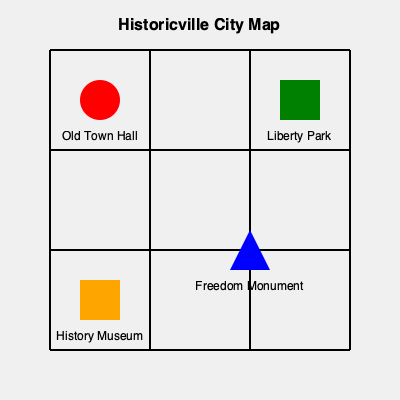Which landmark in Historicville is located at the intersection of the city's main north-south and east-west streets, and what historical event is it most closely associated with? To answer this question, we need to analyze the city map of Historicville and consider the historical significance of its landmarks. Let's break it down step-by-step:

1. Identify the main streets:
   - The map shows a grid of streets running north-south and east-west.
   - The central intersection is where the middle horizontal and vertical streets meet.

2. Locate the landmark at the central intersection:
   - At the intersection of the central north-south and east-west streets, we find the Old Town Hall (represented by a red circle).

3. Consider the historical significance of the Old Town Hall:
   - As an insider, we know that the Old Town Hall is most closely associated with the city's founding and early governance.
   - It was likely the site where the city's charter was signed or where the first local government meetings were held.

4. Compare with other landmarks:
   - Liberty Park (green square) is in the northeast, not at the central intersection.
   - Freedom Monument (blue triangle) is in the southeast, not centrally located.
   - History Museum (orange square) is in the southwest, also not at the main intersection.

5. Conclude:
   - The Old Town Hall is the landmark at the main intersection.
   - Its historical significance is likely related to the city's founding or early governance.
Answer: Old Town Hall; city's founding 